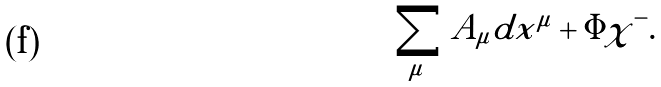Convert formula to latex. <formula><loc_0><loc_0><loc_500><loc_500>\sum _ { \mu } A _ { \mu } d x ^ { \mu } + { \Phi } \chi ^ { - } .</formula> 